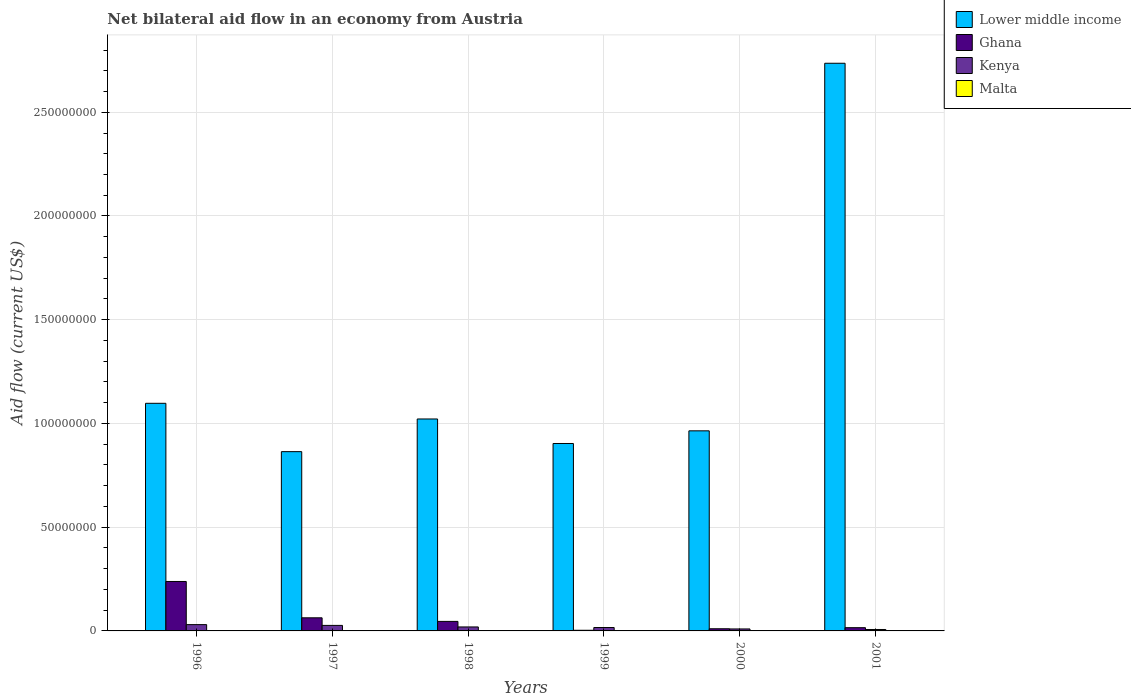How many different coloured bars are there?
Ensure brevity in your answer.  4. Are the number of bars on each tick of the X-axis equal?
Your response must be concise. Yes. How many bars are there on the 1st tick from the left?
Offer a very short reply. 4. How many bars are there on the 6th tick from the right?
Your answer should be very brief. 4. What is the label of the 6th group of bars from the left?
Offer a very short reply. 2001. What is the net bilateral aid flow in Kenya in 2001?
Provide a succinct answer. 6.90e+05. Across all years, what is the maximum net bilateral aid flow in Kenya?
Your response must be concise. 3.04e+06. Across all years, what is the minimum net bilateral aid flow in Ghana?
Offer a very short reply. 3.10e+05. What is the total net bilateral aid flow in Malta in the graph?
Your answer should be compact. 1.50e+05. What is the difference between the net bilateral aid flow in Lower middle income in 1998 and the net bilateral aid flow in Ghana in 1996?
Offer a very short reply. 7.83e+07. What is the average net bilateral aid flow in Ghana per year?
Your answer should be very brief. 6.28e+06. In the year 1998, what is the difference between the net bilateral aid flow in Malta and net bilateral aid flow in Lower middle income?
Make the answer very short. -1.02e+08. In how many years, is the net bilateral aid flow in Ghana greater than 40000000 US$?
Give a very brief answer. 0. What is the ratio of the net bilateral aid flow in Malta in 1996 to that in 1998?
Your response must be concise. 1.33. What is the difference between the highest and the second highest net bilateral aid flow in Lower middle income?
Provide a succinct answer. 1.64e+08. What is the difference between the highest and the lowest net bilateral aid flow in Malta?
Offer a terse response. 3.00e+04. Is it the case that in every year, the sum of the net bilateral aid flow in Lower middle income and net bilateral aid flow in Kenya is greater than the sum of net bilateral aid flow in Malta and net bilateral aid flow in Ghana?
Offer a very short reply. No. What does the 1st bar from the left in 1999 represents?
Offer a terse response. Lower middle income. How many bars are there?
Make the answer very short. 24. How many years are there in the graph?
Your answer should be compact. 6. Are the values on the major ticks of Y-axis written in scientific E-notation?
Provide a short and direct response. No. Does the graph contain grids?
Give a very brief answer. Yes. How are the legend labels stacked?
Offer a terse response. Vertical. What is the title of the graph?
Your answer should be very brief. Net bilateral aid flow in an economy from Austria. Does "Curacao" appear as one of the legend labels in the graph?
Make the answer very short. No. What is the label or title of the Y-axis?
Give a very brief answer. Aid flow (current US$). What is the Aid flow (current US$) of Lower middle income in 1996?
Your response must be concise. 1.10e+08. What is the Aid flow (current US$) of Ghana in 1996?
Your answer should be very brief. 2.38e+07. What is the Aid flow (current US$) of Kenya in 1996?
Make the answer very short. 3.04e+06. What is the Aid flow (current US$) in Lower middle income in 1997?
Offer a terse response. 8.64e+07. What is the Aid flow (current US$) in Ghana in 1997?
Provide a short and direct response. 6.32e+06. What is the Aid flow (current US$) in Kenya in 1997?
Offer a terse response. 2.66e+06. What is the Aid flow (current US$) of Lower middle income in 1998?
Ensure brevity in your answer.  1.02e+08. What is the Aid flow (current US$) of Ghana in 1998?
Offer a very short reply. 4.59e+06. What is the Aid flow (current US$) of Kenya in 1998?
Give a very brief answer. 1.92e+06. What is the Aid flow (current US$) in Lower middle income in 1999?
Provide a short and direct response. 9.03e+07. What is the Aid flow (current US$) of Kenya in 1999?
Keep it short and to the point. 1.64e+06. What is the Aid flow (current US$) in Lower middle income in 2000?
Provide a succinct answer. 9.64e+07. What is the Aid flow (current US$) in Ghana in 2000?
Your response must be concise. 1.04e+06. What is the Aid flow (current US$) of Kenya in 2000?
Your answer should be very brief. 9.50e+05. What is the Aid flow (current US$) in Lower middle income in 2001?
Provide a short and direct response. 2.74e+08. What is the Aid flow (current US$) in Ghana in 2001?
Provide a succinct answer. 1.56e+06. What is the Aid flow (current US$) in Kenya in 2001?
Keep it short and to the point. 6.90e+05. Across all years, what is the maximum Aid flow (current US$) in Lower middle income?
Provide a short and direct response. 2.74e+08. Across all years, what is the maximum Aid flow (current US$) in Ghana?
Your answer should be very brief. 2.38e+07. Across all years, what is the maximum Aid flow (current US$) in Kenya?
Give a very brief answer. 3.04e+06. Across all years, what is the maximum Aid flow (current US$) of Malta?
Your response must be concise. 4.00e+04. Across all years, what is the minimum Aid flow (current US$) of Lower middle income?
Your answer should be very brief. 8.64e+07. Across all years, what is the minimum Aid flow (current US$) in Kenya?
Provide a succinct answer. 6.90e+05. Across all years, what is the minimum Aid flow (current US$) of Malta?
Give a very brief answer. 10000. What is the total Aid flow (current US$) of Lower middle income in the graph?
Make the answer very short. 7.59e+08. What is the total Aid flow (current US$) in Ghana in the graph?
Keep it short and to the point. 3.76e+07. What is the total Aid flow (current US$) of Kenya in the graph?
Give a very brief answer. 1.09e+07. What is the difference between the Aid flow (current US$) of Lower middle income in 1996 and that in 1997?
Ensure brevity in your answer.  2.33e+07. What is the difference between the Aid flow (current US$) of Ghana in 1996 and that in 1997?
Give a very brief answer. 1.75e+07. What is the difference between the Aid flow (current US$) in Malta in 1996 and that in 1997?
Your response must be concise. 2.00e+04. What is the difference between the Aid flow (current US$) of Lower middle income in 1996 and that in 1998?
Give a very brief answer. 7.55e+06. What is the difference between the Aid flow (current US$) in Ghana in 1996 and that in 1998?
Provide a succinct answer. 1.92e+07. What is the difference between the Aid flow (current US$) in Kenya in 1996 and that in 1998?
Ensure brevity in your answer.  1.12e+06. What is the difference between the Aid flow (current US$) in Malta in 1996 and that in 1998?
Provide a succinct answer. 10000. What is the difference between the Aid flow (current US$) of Lower middle income in 1996 and that in 1999?
Ensure brevity in your answer.  1.94e+07. What is the difference between the Aid flow (current US$) in Ghana in 1996 and that in 1999?
Provide a succinct answer. 2.35e+07. What is the difference between the Aid flow (current US$) of Kenya in 1996 and that in 1999?
Offer a terse response. 1.40e+06. What is the difference between the Aid flow (current US$) of Lower middle income in 1996 and that in 2000?
Offer a terse response. 1.33e+07. What is the difference between the Aid flow (current US$) of Ghana in 1996 and that in 2000?
Provide a short and direct response. 2.28e+07. What is the difference between the Aid flow (current US$) in Kenya in 1996 and that in 2000?
Offer a very short reply. 2.09e+06. What is the difference between the Aid flow (current US$) of Malta in 1996 and that in 2000?
Provide a short and direct response. 2.00e+04. What is the difference between the Aid flow (current US$) of Lower middle income in 1996 and that in 2001?
Offer a terse response. -1.64e+08. What is the difference between the Aid flow (current US$) of Ghana in 1996 and that in 2001?
Give a very brief answer. 2.23e+07. What is the difference between the Aid flow (current US$) of Kenya in 1996 and that in 2001?
Provide a short and direct response. 2.35e+06. What is the difference between the Aid flow (current US$) in Malta in 1996 and that in 2001?
Your answer should be compact. 3.00e+04. What is the difference between the Aid flow (current US$) in Lower middle income in 1997 and that in 1998?
Offer a very short reply. -1.58e+07. What is the difference between the Aid flow (current US$) in Ghana in 1997 and that in 1998?
Your answer should be compact. 1.73e+06. What is the difference between the Aid flow (current US$) of Kenya in 1997 and that in 1998?
Ensure brevity in your answer.  7.40e+05. What is the difference between the Aid flow (current US$) in Lower middle income in 1997 and that in 1999?
Provide a short and direct response. -3.93e+06. What is the difference between the Aid flow (current US$) of Ghana in 1997 and that in 1999?
Your answer should be compact. 6.01e+06. What is the difference between the Aid flow (current US$) of Kenya in 1997 and that in 1999?
Offer a terse response. 1.02e+06. What is the difference between the Aid flow (current US$) of Lower middle income in 1997 and that in 2000?
Provide a short and direct response. -1.00e+07. What is the difference between the Aid flow (current US$) of Ghana in 1997 and that in 2000?
Your answer should be compact. 5.28e+06. What is the difference between the Aid flow (current US$) in Kenya in 1997 and that in 2000?
Your answer should be compact. 1.71e+06. What is the difference between the Aid flow (current US$) in Lower middle income in 1997 and that in 2001?
Keep it short and to the point. -1.87e+08. What is the difference between the Aid flow (current US$) of Ghana in 1997 and that in 2001?
Offer a terse response. 4.76e+06. What is the difference between the Aid flow (current US$) of Kenya in 1997 and that in 2001?
Offer a terse response. 1.97e+06. What is the difference between the Aid flow (current US$) in Malta in 1997 and that in 2001?
Offer a terse response. 10000. What is the difference between the Aid flow (current US$) in Lower middle income in 1998 and that in 1999?
Keep it short and to the point. 1.18e+07. What is the difference between the Aid flow (current US$) of Ghana in 1998 and that in 1999?
Offer a terse response. 4.28e+06. What is the difference between the Aid flow (current US$) in Kenya in 1998 and that in 1999?
Your answer should be compact. 2.80e+05. What is the difference between the Aid flow (current US$) of Malta in 1998 and that in 1999?
Your response must be concise. 0. What is the difference between the Aid flow (current US$) in Lower middle income in 1998 and that in 2000?
Offer a very short reply. 5.72e+06. What is the difference between the Aid flow (current US$) of Ghana in 1998 and that in 2000?
Your answer should be very brief. 3.55e+06. What is the difference between the Aid flow (current US$) in Kenya in 1998 and that in 2000?
Ensure brevity in your answer.  9.70e+05. What is the difference between the Aid flow (current US$) of Lower middle income in 1998 and that in 2001?
Provide a short and direct response. -1.71e+08. What is the difference between the Aid flow (current US$) in Ghana in 1998 and that in 2001?
Your answer should be very brief. 3.03e+06. What is the difference between the Aid flow (current US$) in Kenya in 1998 and that in 2001?
Offer a very short reply. 1.23e+06. What is the difference between the Aid flow (current US$) of Malta in 1998 and that in 2001?
Offer a very short reply. 2.00e+04. What is the difference between the Aid flow (current US$) in Lower middle income in 1999 and that in 2000?
Offer a terse response. -6.10e+06. What is the difference between the Aid flow (current US$) of Ghana in 1999 and that in 2000?
Make the answer very short. -7.30e+05. What is the difference between the Aid flow (current US$) of Kenya in 1999 and that in 2000?
Your answer should be compact. 6.90e+05. What is the difference between the Aid flow (current US$) in Lower middle income in 1999 and that in 2001?
Your response must be concise. -1.83e+08. What is the difference between the Aid flow (current US$) in Ghana in 1999 and that in 2001?
Your answer should be compact. -1.25e+06. What is the difference between the Aid flow (current US$) in Kenya in 1999 and that in 2001?
Offer a very short reply. 9.50e+05. What is the difference between the Aid flow (current US$) in Lower middle income in 2000 and that in 2001?
Offer a terse response. -1.77e+08. What is the difference between the Aid flow (current US$) in Ghana in 2000 and that in 2001?
Your answer should be very brief. -5.20e+05. What is the difference between the Aid flow (current US$) of Kenya in 2000 and that in 2001?
Keep it short and to the point. 2.60e+05. What is the difference between the Aid flow (current US$) of Lower middle income in 1996 and the Aid flow (current US$) of Ghana in 1997?
Offer a terse response. 1.03e+08. What is the difference between the Aid flow (current US$) in Lower middle income in 1996 and the Aid flow (current US$) in Kenya in 1997?
Offer a terse response. 1.07e+08. What is the difference between the Aid flow (current US$) of Lower middle income in 1996 and the Aid flow (current US$) of Malta in 1997?
Offer a terse response. 1.10e+08. What is the difference between the Aid flow (current US$) of Ghana in 1996 and the Aid flow (current US$) of Kenya in 1997?
Make the answer very short. 2.12e+07. What is the difference between the Aid flow (current US$) of Ghana in 1996 and the Aid flow (current US$) of Malta in 1997?
Provide a short and direct response. 2.38e+07. What is the difference between the Aid flow (current US$) in Kenya in 1996 and the Aid flow (current US$) in Malta in 1997?
Your answer should be very brief. 3.02e+06. What is the difference between the Aid flow (current US$) in Lower middle income in 1996 and the Aid flow (current US$) in Ghana in 1998?
Your response must be concise. 1.05e+08. What is the difference between the Aid flow (current US$) in Lower middle income in 1996 and the Aid flow (current US$) in Kenya in 1998?
Ensure brevity in your answer.  1.08e+08. What is the difference between the Aid flow (current US$) of Lower middle income in 1996 and the Aid flow (current US$) of Malta in 1998?
Your answer should be very brief. 1.10e+08. What is the difference between the Aid flow (current US$) of Ghana in 1996 and the Aid flow (current US$) of Kenya in 1998?
Ensure brevity in your answer.  2.19e+07. What is the difference between the Aid flow (current US$) in Ghana in 1996 and the Aid flow (current US$) in Malta in 1998?
Offer a very short reply. 2.38e+07. What is the difference between the Aid flow (current US$) of Kenya in 1996 and the Aid flow (current US$) of Malta in 1998?
Provide a short and direct response. 3.01e+06. What is the difference between the Aid flow (current US$) of Lower middle income in 1996 and the Aid flow (current US$) of Ghana in 1999?
Provide a succinct answer. 1.09e+08. What is the difference between the Aid flow (current US$) of Lower middle income in 1996 and the Aid flow (current US$) of Kenya in 1999?
Ensure brevity in your answer.  1.08e+08. What is the difference between the Aid flow (current US$) in Lower middle income in 1996 and the Aid flow (current US$) in Malta in 1999?
Ensure brevity in your answer.  1.10e+08. What is the difference between the Aid flow (current US$) in Ghana in 1996 and the Aid flow (current US$) in Kenya in 1999?
Give a very brief answer. 2.22e+07. What is the difference between the Aid flow (current US$) of Ghana in 1996 and the Aid flow (current US$) of Malta in 1999?
Offer a very short reply. 2.38e+07. What is the difference between the Aid flow (current US$) in Kenya in 1996 and the Aid flow (current US$) in Malta in 1999?
Offer a very short reply. 3.01e+06. What is the difference between the Aid flow (current US$) of Lower middle income in 1996 and the Aid flow (current US$) of Ghana in 2000?
Ensure brevity in your answer.  1.09e+08. What is the difference between the Aid flow (current US$) in Lower middle income in 1996 and the Aid flow (current US$) in Kenya in 2000?
Provide a succinct answer. 1.09e+08. What is the difference between the Aid flow (current US$) in Lower middle income in 1996 and the Aid flow (current US$) in Malta in 2000?
Your answer should be compact. 1.10e+08. What is the difference between the Aid flow (current US$) of Ghana in 1996 and the Aid flow (current US$) of Kenya in 2000?
Your answer should be compact. 2.29e+07. What is the difference between the Aid flow (current US$) of Ghana in 1996 and the Aid flow (current US$) of Malta in 2000?
Your answer should be very brief. 2.38e+07. What is the difference between the Aid flow (current US$) in Kenya in 1996 and the Aid flow (current US$) in Malta in 2000?
Provide a short and direct response. 3.02e+06. What is the difference between the Aid flow (current US$) in Lower middle income in 1996 and the Aid flow (current US$) in Ghana in 2001?
Keep it short and to the point. 1.08e+08. What is the difference between the Aid flow (current US$) of Lower middle income in 1996 and the Aid flow (current US$) of Kenya in 2001?
Your response must be concise. 1.09e+08. What is the difference between the Aid flow (current US$) in Lower middle income in 1996 and the Aid flow (current US$) in Malta in 2001?
Provide a short and direct response. 1.10e+08. What is the difference between the Aid flow (current US$) of Ghana in 1996 and the Aid flow (current US$) of Kenya in 2001?
Give a very brief answer. 2.31e+07. What is the difference between the Aid flow (current US$) of Ghana in 1996 and the Aid flow (current US$) of Malta in 2001?
Ensure brevity in your answer.  2.38e+07. What is the difference between the Aid flow (current US$) of Kenya in 1996 and the Aid flow (current US$) of Malta in 2001?
Keep it short and to the point. 3.03e+06. What is the difference between the Aid flow (current US$) in Lower middle income in 1997 and the Aid flow (current US$) in Ghana in 1998?
Make the answer very short. 8.18e+07. What is the difference between the Aid flow (current US$) in Lower middle income in 1997 and the Aid flow (current US$) in Kenya in 1998?
Offer a terse response. 8.45e+07. What is the difference between the Aid flow (current US$) of Lower middle income in 1997 and the Aid flow (current US$) of Malta in 1998?
Your answer should be compact. 8.64e+07. What is the difference between the Aid flow (current US$) of Ghana in 1997 and the Aid flow (current US$) of Kenya in 1998?
Ensure brevity in your answer.  4.40e+06. What is the difference between the Aid flow (current US$) of Ghana in 1997 and the Aid flow (current US$) of Malta in 1998?
Ensure brevity in your answer.  6.29e+06. What is the difference between the Aid flow (current US$) in Kenya in 1997 and the Aid flow (current US$) in Malta in 1998?
Offer a terse response. 2.63e+06. What is the difference between the Aid flow (current US$) in Lower middle income in 1997 and the Aid flow (current US$) in Ghana in 1999?
Give a very brief answer. 8.61e+07. What is the difference between the Aid flow (current US$) of Lower middle income in 1997 and the Aid flow (current US$) of Kenya in 1999?
Offer a terse response. 8.48e+07. What is the difference between the Aid flow (current US$) of Lower middle income in 1997 and the Aid flow (current US$) of Malta in 1999?
Your answer should be compact. 8.64e+07. What is the difference between the Aid flow (current US$) in Ghana in 1997 and the Aid flow (current US$) in Kenya in 1999?
Offer a very short reply. 4.68e+06. What is the difference between the Aid flow (current US$) of Ghana in 1997 and the Aid flow (current US$) of Malta in 1999?
Offer a terse response. 6.29e+06. What is the difference between the Aid flow (current US$) of Kenya in 1997 and the Aid flow (current US$) of Malta in 1999?
Keep it short and to the point. 2.63e+06. What is the difference between the Aid flow (current US$) in Lower middle income in 1997 and the Aid flow (current US$) in Ghana in 2000?
Give a very brief answer. 8.54e+07. What is the difference between the Aid flow (current US$) of Lower middle income in 1997 and the Aid flow (current US$) of Kenya in 2000?
Provide a succinct answer. 8.55e+07. What is the difference between the Aid flow (current US$) of Lower middle income in 1997 and the Aid flow (current US$) of Malta in 2000?
Provide a short and direct response. 8.64e+07. What is the difference between the Aid flow (current US$) of Ghana in 1997 and the Aid flow (current US$) of Kenya in 2000?
Ensure brevity in your answer.  5.37e+06. What is the difference between the Aid flow (current US$) in Ghana in 1997 and the Aid flow (current US$) in Malta in 2000?
Offer a terse response. 6.30e+06. What is the difference between the Aid flow (current US$) in Kenya in 1997 and the Aid flow (current US$) in Malta in 2000?
Your response must be concise. 2.64e+06. What is the difference between the Aid flow (current US$) in Lower middle income in 1997 and the Aid flow (current US$) in Ghana in 2001?
Keep it short and to the point. 8.48e+07. What is the difference between the Aid flow (current US$) of Lower middle income in 1997 and the Aid flow (current US$) of Kenya in 2001?
Give a very brief answer. 8.57e+07. What is the difference between the Aid flow (current US$) in Lower middle income in 1997 and the Aid flow (current US$) in Malta in 2001?
Provide a short and direct response. 8.64e+07. What is the difference between the Aid flow (current US$) of Ghana in 1997 and the Aid flow (current US$) of Kenya in 2001?
Your answer should be compact. 5.63e+06. What is the difference between the Aid flow (current US$) of Ghana in 1997 and the Aid flow (current US$) of Malta in 2001?
Your response must be concise. 6.31e+06. What is the difference between the Aid flow (current US$) of Kenya in 1997 and the Aid flow (current US$) of Malta in 2001?
Your response must be concise. 2.65e+06. What is the difference between the Aid flow (current US$) in Lower middle income in 1998 and the Aid flow (current US$) in Ghana in 1999?
Your answer should be very brief. 1.02e+08. What is the difference between the Aid flow (current US$) of Lower middle income in 1998 and the Aid flow (current US$) of Kenya in 1999?
Provide a short and direct response. 1.01e+08. What is the difference between the Aid flow (current US$) in Lower middle income in 1998 and the Aid flow (current US$) in Malta in 1999?
Make the answer very short. 1.02e+08. What is the difference between the Aid flow (current US$) in Ghana in 1998 and the Aid flow (current US$) in Kenya in 1999?
Keep it short and to the point. 2.95e+06. What is the difference between the Aid flow (current US$) in Ghana in 1998 and the Aid flow (current US$) in Malta in 1999?
Your answer should be very brief. 4.56e+06. What is the difference between the Aid flow (current US$) in Kenya in 1998 and the Aid flow (current US$) in Malta in 1999?
Provide a short and direct response. 1.89e+06. What is the difference between the Aid flow (current US$) in Lower middle income in 1998 and the Aid flow (current US$) in Ghana in 2000?
Provide a short and direct response. 1.01e+08. What is the difference between the Aid flow (current US$) of Lower middle income in 1998 and the Aid flow (current US$) of Kenya in 2000?
Offer a terse response. 1.01e+08. What is the difference between the Aid flow (current US$) in Lower middle income in 1998 and the Aid flow (current US$) in Malta in 2000?
Keep it short and to the point. 1.02e+08. What is the difference between the Aid flow (current US$) in Ghana in 1998 and the Aid flow (current US$) in Kenya in 2000?
Make the answer very short. 3.64e+06. What is the difference between the Aid flow (current US$) in Ghana in 1998 and the Aid flow (current US$) in Malta in 2000?
Make the answer very short. 4.57e+06. What is the difference between the Aid flow (current US$) of Kenya in 1998 and the Aid flow (current US$) of Malta in 2000?
Provide a succinct answer. 1.90e+06. What is the difference between the Aid flow (current US$) of Lower middle income in 1998 and the Aid flow (current US$) of Ghana in 2001?
Give a very brief answer. 1.01e+08. What is the difference between the Aid flow (current US$) in Lower middle income in 1998 and the Aid flow (current US$) in Kenya in 2001?
Keep it short and to the point. 1.01e+08. What is the difference between the Aid flow (current US$) of Lower middle income in 1998 and the Aid flow (current US$) of Malta in 2001?
Keep it short and to the point. 1.02e+08. What is the difference between the Aid flow (current US$) of Ghana in 1998 and the Aid flow (current US$) of Kenya in 2001?
Your response must be concise. 3.90e+06. What is the difference between the Aid flow (current US$) in Ghana in 1998 and the Aid flow (current US$) in Malta in 2001?
Your answer should be very brief. 4.58e+06. What is the difference between the Aid flow (current US$) of Kenya in 1998 and the Aid flow (current US$) of Malta in 2001?
Make the answer very short. 1.91e+06. What is the difference between the Aid flow (current US$) in Lower middle income in 1999 and the Aid flow (current US$) in Ghana in 2000?
Provide a succinct answer. 8.93e+07. What is the difference between the Aid flow (current US$) in Lower middle income in 1999 and the Aid flow (current US$) in Kenya in 2000?
Keep it short and to the point. 8.94e+07. What is the difference between the Aid flow (current US$) in Lower middle income in 1999 and the Aid flow (current US$) in Malta in 2000?
Ensure brevity in your answer.  9.03e+07. What is the difference between the Aid flow (current US$) in Ghana in 1999 and the Aid flow (current US$) in Kenya in 2000?
Your answer should be very brief. -6.40e+05. What is the difference between the Aid flow (current US$) in Ghana in 1999 and the Aid flow (current US$) in Malta in 2000?
Ensure brevity in your answer.  2.90e+05. What is the difference between the Aid flow (current US$) of Kenya in 1999 and the Aid flow (current US$) of Malta in 2000?
Provide a succinct answer. 1.62e+06. What is the difference between the Aid flow (current US$) in Lower middle income in 1999 and the Aid flow (current US$) in Ghana in 2001?
Your answer should be very brief. 8.88e+07. What is the difference between the Aid flow (current US$) in Lower middle income in 1999 and the Aid flow (current US$) in Kenya in 2001?
Give a very brief answer. 8.96e+07. What is the difference between the Aid flow (current US$) in Lower middle income in 1999 and the Aid flow (current US$) in Malta in 2001?
Give a very brief answer. 9.03e+07. What is the difference between the Aid flow (current US$) of Ghana in 1999 and the Aid flow (current US$) of Kenya in 2001?
Give a very brief answer. -3.80e+05. What is the difference between the Aid flow (current US$) of Kenya in 1999 and the Aid flow (current US$) of Malta in 2001?
Your answer should be very brief. 1.63e+06. What is the difference between the Aid flow (current US$) of Lower middle income in 2000 and the Aid flow (current US$) of Ghana in 2001?
Ensure brevity in your answer.  9.49e+07. What is the difference between the Aid flow (current US$) of Lower middle income in 2000 and the Aid flow (current US$) of Kenya in 2001?
Keep it short and to the point. 9.58e+07. What is the difference between the Aid flow (current US$) in Lower middle income in 2000 and the Aid flow (current US$) in Malta in 2001?
Make the answer very short. 9.64e+07. What is the difference between the Aid flow (current US$) of Ghana in 2000 and the Aid flow (current US$) of Malta in 2001?
Your answer should be very brief. 1.03e+06. What is the difference between the Aid flow (current US$) of Kenya in 2000 and the Aid flow (current US$) of Malta in 2001?
Ensure brevity in your answer.  9.40e+05. What is the average Aid flow (current US$) in Lower middle income per year?
Your answer should be compact. 1.26e+08. What is the average Aid flow (current US$) in Ghana per year?
Make the answer very short. 6.28e+06. What is the average Aid flow (current US$) of Kenya per year?
Offer a terse response. 1.82e+06. What is the average Aid flow (current US$) in Malta per year?
Your answer should be compact. 2.50e+04. In the year 1996, what is the difference between the Aid flow (current US$) in Lower middle income and Aid flow (current US$) in Ghana?
Provide a succinct answer. 8.59e+07. In the year 1996, what is the difference between the Aid flow (current US$) in Lower middle income and Aid flow (current US$) in Kenya?
Give a very brief answer. 1.07e+08. In the year 1996, what is the difference between the Aid flow (current US$) of Lower middle income and Aid flow (current US$) of Malta?
Keep it short and to the point. 1.10e+08. In the year 1996, what is the difference between the Aid flow (current US$) in Ghana and Aid flow (current US$) in Kenya?
Keep it short and to the point. 2.08e+07. In the year 1996, what is the difference between the Aid flow (current US$) of Ghana and Aid flow (current US$) of Malta?
Ensure brevity in your answer.  2.38e+07. In the year 1997, what is the difference between the Aid flow (current US$) of Lower middle income and Aid flow (current US$) of Ghana?
Provide a succinct answer. 8.01e+07. In the year 1997, what is the difference between the Aid flow (current US$) in Lower middle income and Aid flow (current US$) in Kenya?
Offer a very short reply. 8.38e+07. In the year 1997, what is the difference between the Aid flow (current US$) in Lower middle income and Aid flow (current US$) in Malta?
Make the answer very short. 8.64e+07. In the year 1997, what is the difference between the Aid flow (current US$) of Ghana and Aid flow (current US$) of Kenya?
Your response must be concise. 3.66e+06. In the year 1997, what is the difference between the Aid flow (current US$) of Ghana and Aid flow (current US$) of Malta?
Keep it short and to the point. 6.30e+06. In the year 1997, what is the difference between the Aid flow (current US$) in Kenya and Aid flow (current US$) in Malta?
Offer a terse response. 2.64e+06. In the year 1998, what is the difference between the Aid flow (current US$) of Lower middle income and Aid flow (current US$) of Ghana?
Ensure brevity in your answer.  9.76e+07. In the year 1998, what is the difference between the Aid flow (current US$) of Lower middle income and Aid flow (current US$) of Kenya?
Offer a very short reply. 1.00e+08. In the year 1998, what is the difference between the Aid flow (current US$) of Lower middle income and Aid flow (current US$) of Malta?
Give a very brief answer. 1.02e+08. In the year 1998, what is the difference between the Aid flow (current US$) of Ghana and Aid flow (current US$) of Kenya?
Your answer should be very brief. 2.67e+06. In the year 1998, what is the difference between the Aid flow (current US$) in Ghana and Aid flow (current US$) in Malta?
Give a very brief answer. 4.56e+06. In the year 1998, what is the difference between the Aid flow (current US$) in Kenya and Aid flow (current US$) in Malta?
Make the answer very short. 1.89e+06. In the year 1999, what is the difference between the Aid flow (current US$) in Lower middle income and Aid flow (current US$) in Ghana?
Ensure brevity in your answer.  9.00e+07. In the year 1999, what is the difference between the Aid flow (current US$) in Lower middle income and Aid flow (current US$) in Kenya?
Offer a very short reply. 8.87e+07. In the year 1999, what is the difference between the Aid flow (current US$) of Lower middle income and Aid flow (current US$) of Malta?
Provide a succinct answer. 9.03e+07. In the year 1999, what is the difference between the Aid flow (current US$) in Ghana and Aid flow (current US$) in Kenya?
Make the answer very short. -1.33e+06. In the year 1999, what is the difference between the Aid flow (current US$) of Ghana and Aid flow (current US$) of Malta?
Offer a very short reply. 2.80e+05. In the year 1999, what is the difference between the Aid flow (current US$) in Kenya and Aid flow (current US$) in Malta?
Your response must be concise. 1.61e+06. In the year 2000, what is the difference between the Aid flow (current US$) of Lower middle income and Aid flow (current US$) of Ghana?
Offer a very short reply. 9.54e+07. In the year 2000, what is the difference between the Aid flow (current US$) of Lower middle income and Aid flow (current US$) of Kenya?
Keep it short and to the point. 9.55e+07. In the year 2000, what is the difference between the Aid flow (current US$) in Lower middle income and Aid flow (current US$) in Malta?
Give a very brief answer. 9.64e+07. In the year 2000, what is the difference between the Aid flow (current US$) of Ghana and Aid flow (current US$) of Kenya?
Give a very brief answer. 9.00e+04. In the year 2000, what is the difference between the Aid flow (current US$) in Ghana and Aid flow (current US$) in Malta?
Your response must be concise. 1.02e+06. In the year 2000, what is the difference between the Aid flow (current US$) in Kenya and Aid flow (current US$) in Malta?
Offer a very short reply. 9.30e+05. In the year 2001, what is the difference between the Aid flow (current US$) of Lower middle income and Aid flow (current US$) of Ghana?
Keep it short and to the point. 2.72e+08. In the year 2001, what is the difference between the Aid flow (current US$) in Lower middle income and Aid flow (current US$) in Kenya?
Offer a terse response. 2.73e+08. In the year 2001, what is the difference between the Aid flow (current US$) in Lower middle income and Aid flow (current US$) in Malta?
Your answer should be compact. 2.74e+08. In the year 2001, what is the difference between the Aid flow (current US$) in Ghana and Aid flow (current US$) in Kenya?
Keep it short and to the point. 8.70e+05. In the year 2001, what is the difference between the Aid flow (current US$) of Ghana and Aid flow (current US$) of Malta?
Offer a very short reply. 1.55e+06. In the year 2001, what is the difference between the Aid flow (current US$) of Kenya and Aid flow (current US$) of Malta?
Provide a short and direct response. 6.80e+05. What is the ratio of the Aid flow (current US$) of Lower middle income in 1996 to that in 1997?
Your response must be concise. 1.27. What is the ratio of the Aid flow (current US$) in Ghana in 1996 to that in 1997?
Provide a short and direct response. 3.77. What is the ratio of the Aid flow (current US$) in Malta in 1996 to that in 1997?
Your answer should be very brief. 2. What is the ratio of the Aid flow (current US$) of Lower middle income in 1996 to that in 1998?
Offer a terse response. 1.07. What is the ratio of the Aid flow (current US$) in Ghana in 1996 to that in 1998?
Offer a terse response. 5.19. What is the ratio of the Aid flow (current US$) of Kenya in 1996 to that in 1998?
Keep it short and to the point. 1.58. What is the ratio of the Aid flow (current US$) in Lower middle income in 1996 to that in 1999?
Provide a short and direct response. 1.21. What is the ratio of the Aid flow (current US$) of Ghana in 1996 to that in 1999?
Make the answer very short. 76.87. What is the ratio of the Aid flow (current US$) in Kenya in 1996 to that in 1999?
Keep it short and to the point. 1.85. What is the ratio of the Aid flow (current US$) of Lower middle income in 1996 to that in 2000?
Your response must be concise. 1.14. What is the ratio of the Aid flow (current US$) of Ghana in 1996 to that in 2000?
Ensure brevity in your answer.  22.91. What is the ratio of the Aid flow (current US$) in Malta in 1996 to that in 2000?
Provide a succinct answer. 2. What is the ratio of the Aid flow (current US$) in Lower middle income in 1996 to that in 2001?
Ensure brevity in your answer.  0.4. What is the ratio of the Aid flow (current US$) of Ghana in 1996 to that in 2001?
Give a very brief answer. 15.28. What is the ratio of the Aid flow (current US$) of Kenya in 1996 to that in 2001?
Keep it short and to the point. 4.41. What is the ratio of the Aid flow (current US$) in Malta in 1996 to that in 2001?
Offer a very short reply. 4. What is the ratio of the Aid flow (current US$) of Lower middle income in 1997 to that in 1998?
Make the answer very short. 0.85. What is the ratio of the Aid flow (current US$) of Ghana in 1997 to that in 1998?
Provide a succinct answer. 1.38. What is the ratio of the Aid flow (current US$) of Kenya in 1997 to that in 1998?
Your answer should be compact. 1.39. What is the ratio of the Aid flow (current US$) of Lower middle income in 1997 to that in 1999?
Your answer should be compact. 0.96. What is the ratio of the Aid flow (current US$) of Ghana in 1997 to that in 1999?
Your answer should be very brief. 20.39. What is the ratio of the Aid flow (current US$) of Kenya in 1997 to that in 1999?
Your answer should be very brief. 1.62. What is the ratio of the Aid flow (current US$) of Malta in 1997 to that in 1999?
Make the answer very short. 0.67. What is the ratio of the Aid flow (current US$) in Lower middle income in 1997 to that in 2000?
Your answer should be very brief. 0.9. What is the ratio of the Aid flow (current US$) in Ghana in 1997 to that in 2000?
Provide a succinct answer. 6.08. What is the ratio of the Aid flow (current US$) of Malta in 1997 to that in 2000?
Offer a very short reply. 1. What is the ratio of the Aid flow (current US$) of Lower middle income in 1997 to that in 2001?
Your answer should be very brief. 0.32. What is the ratio of the Aid flow (current US$) of Ghana in 1997 to that in 2001?
Your answer should be very brief. 4.05. What is the ratio of the Aid flow (current US$) of Kenya in 1997 to that in 2001?
Provide a short and direct response. 3.86. What is the ratio of the Aid flow (current US$) in Lower middle income in 1998 to that in 1999?
Offer a terse response. 1.13. What is the ratio of the Aid flow (current US$) of Ghana in 1998 to that in 1999?
Ensure brevity in your answer.  14.81. What is the ratio of the Aid flow (current US$) in Kenya in 1998 to that in 1999?
Your answer should be compact. 1.17. What is the ratio of the Aid flow (current US$) of Malta in 1998 to that in 1999?
Your answer should be compact. 1. What is the ratio of the Aid flow (current US$) in Lower middle income in 1998 to that in 2000?
Keep it short and to the point. 1.06. What is the ratio of the Aid flow (current US$) of Ghana in 1998 to that in 2000?
Make the answer very short. 4.41. What is the ratio of the Aid flow (current US$) in Kenya in 1998 to that in 2000?
Keep it short and to the point. 2.02. What is the ratio of the Aid flow (current US$) in Lower middle income in 1998 to that in 2001?
Ensure brevity in your answer.  0.37. What is the ratio of the Aid flow (current US$) of Ghana in 1998 to that in 2001?
Offer a very short reply. 2.94. What is the ratio of the Aid flow (current US$) of Kenya in 1998 to that in 2001?
Your response must be concise. 2.78. What is the ratio of the Aid flow (current US$) in Malta in 1998 to that in 2001?
Give a very brief answer. 3. What is the ratio of the Aid flow (current US$) in Lower middle income in 1999 to that in 2000?
Give a very brief answer. 0.94. What is the ratio of the Aid flow (current US$) in Ghana in 1999 to that in 2000?
Offer a terse response. 0.3. What is the ratio of the Aid flow (current US$) in Kenya in 1999 to that in 2000?
Offer a terse response. 1.73. What is the ratio of the Aid flow (current US$) of Malta in 1999 to that in 2000?
Give a very brief answer. 1.5. What is the ratio of the Aid flow (current US$) of Lower middle income in 1999 to that in 2001?
Provide a succinct answer. 0.33. What is the ratio of the Aid flow (current US$) in Ghana in 1999 to that in 2001?
Your answer should be compact. 0.2. What is the ratio of the Aid flow (current US$) of Kenya in 1999 to that in 2001?
Offer a very short reply. 2.38. What is the ratio of the Aid flow (current US$) of Malta in 1999 to that in 2001?
Your answer should be very brief. 3. What is the ratio of the Aid flow (current US$) in Lower middle income in 2000 to that in 2001?
Offer a very short reply. 0.35. What is the ratio of the Aid flow (current US$) of Ghana in 2000 to that in 2001?
Give a very brief answer. 0.67. What is the ratio of the Aid flow (current US$) in Kenya in 2000 to that in 2001?
Offer a terse response. 1.38. What is the ratio of the Aid flow (current US$) in Malta in 2000 to that in 2001?
Your answer should be compact. 2. What is the difference between the highest and the second highest Aid flow (current US$) of Lower middle income?
Provide a succinct answer. 1.64e+08. What is the difference between the highest and the second highest Aid flow (current US$) in Ghana?
Your response must be concise. 1.75e+07. What is the difference between the highest and the second highest Aid flow (current US$) of Kenya?
Make the answer very short. 3.80e+05. What is the difference between the highest and the lowest Aid flow (current US$) of Lower middle income?
Keep it short and to the point. 1.87e+08. What is the difference between the highest and the lowest Aid flow (current US$) in Ghana?
Provide a succinct answer. 2.35e+07. What is the difference between the highest and the lowest Aid flow (current US$) of Kenya?
Make the answer very short. 2.35e+06. What is the difference between the highest and the lowest Aid flow (current US$) of Malta?
Provide a short and direct response. 3.00e+04. 